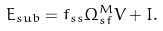<formula> <loc_0><loc_0><loc_500><loc_500>E _ { s u b } = f _ { s s } \Omega ^ { M } _ { s f } V + I .</formula> 